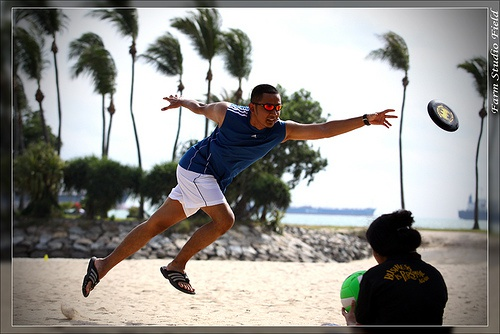Describe the objects in this image and their specific colors. I can see people in black, maroon, darkgray, and lightgray tones, people in black, darkgray, white, and gray tones, frisbee in black, gray, darkgray, and lightgray tones, sports ball in black, green, darkgray, and darkgreen tones, and boat in black, darkgray, lightblue, and lavender tones in this image. 